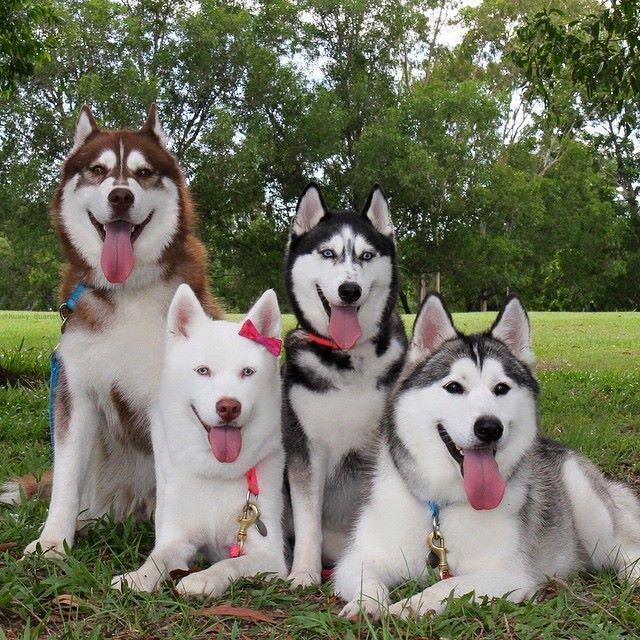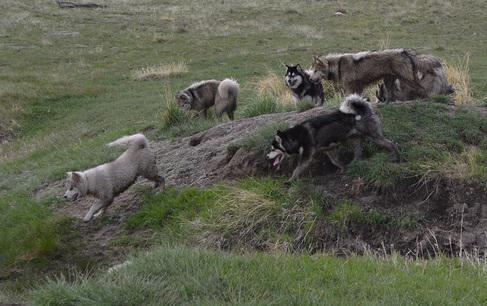The first image is the image on the left, the second image is the image on the right. Analyze the images presented: Is the assertion "there are at least 6 husky dogs on a grassy hill" valid? Answer yes or no. Yes. The first image is the image on the left, the second image is the image on the right. Examine the images to the left and right. Is the description "There are dogs with sheep in each image" accurate? Answer yes or no. No. 